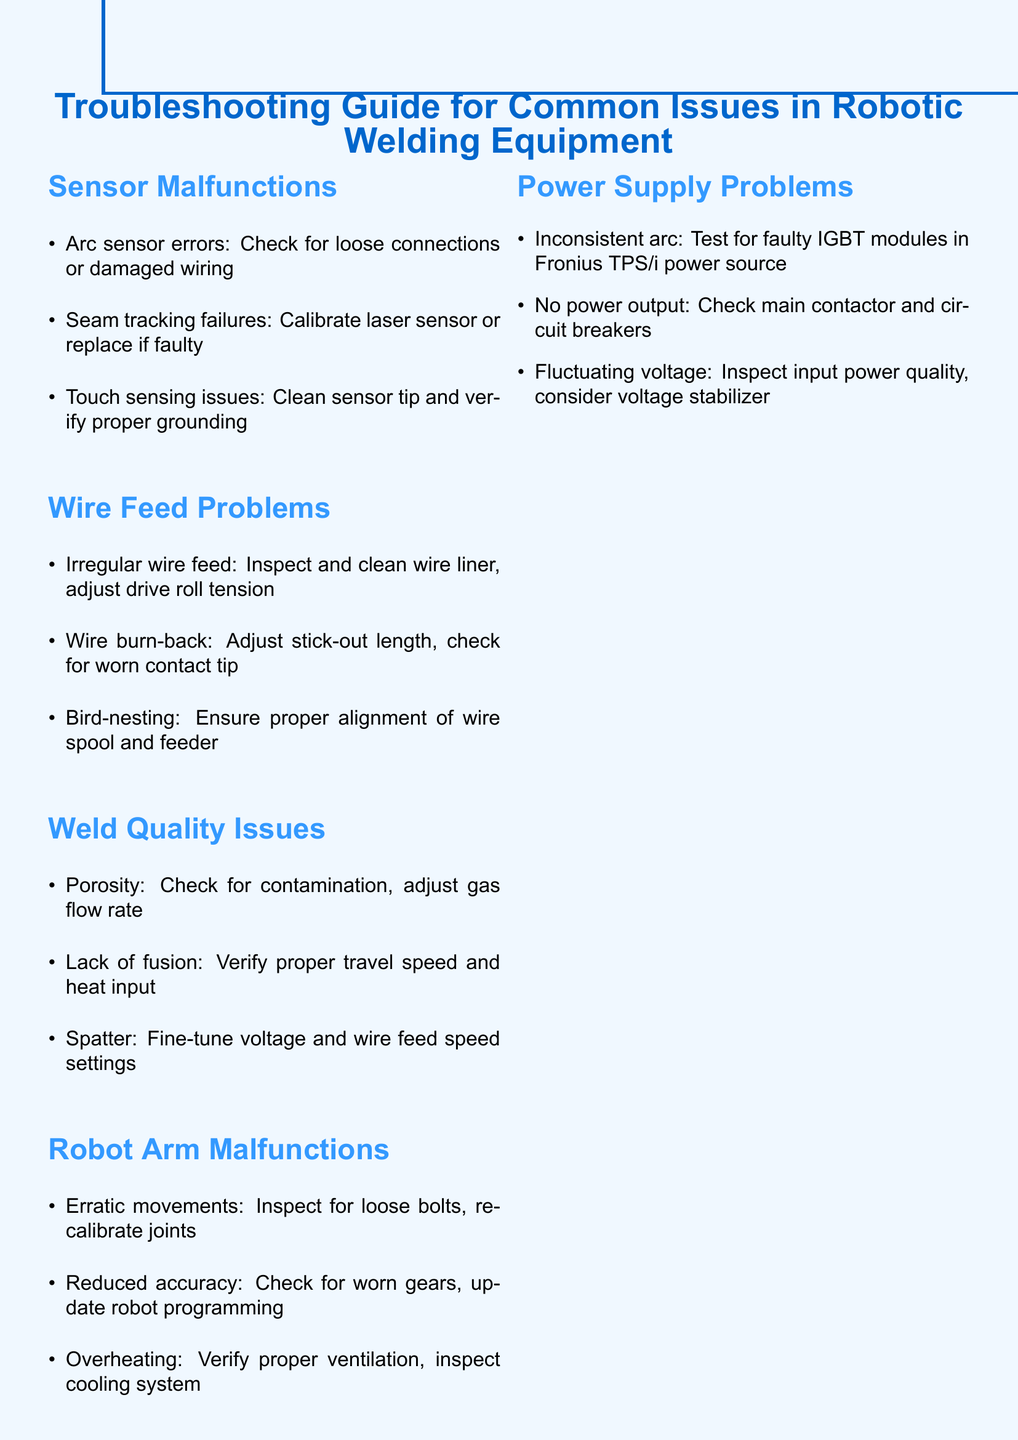What is the first item listed under Sensor Malfunctions? The first item listed is related to arc sensor errors, which states to check for loose connections or damaged wiring.
Answer: Arc sensor errors: Check for loose connections or damaged wiring How many items are listed under Wire Feed Problems? There are a total of three items listed under Wire Feed Problems that describe various issues.
Answer: 3 What should you do if you encounter inconsistent arc? The document suggests testing for faulty IGBT modules in the Fronius TPS/i power source as a troubleshooting step.
Answer: Test for faulty IGBT modules in Fronius TPS/i power source What is a suggested remedy for irregular wire feed? One of the remedies is to inspect and clean the wire liner, as well as adjusting drive roll tension.
Answer: Inspect and clean wire liner, adjust drive roll tension Which section covers issues related to weld quality? The section titled "Weld Quality Issues" specifically addresses problems related to the quality of the weld.
Answer: Weld Quality Issues What is a general note provided at the end of the document? The document includes several general notes, one of which is to always consult the manufacturer's manual for specific troubleshooting steps.
Answer: Always consult the manufacturer's manual for specific troubleshooting steps What issue is addressed if the robot arm experiences erratic movements? The recommended action is to inspect for loose bolts and recalibrate joints, which pertains directly to erratic movements.
Answer: Inspect for loose bolts, recalibrate joints How should one handle power supply problems according to the guide? The guide suggests checking the main contactor and circuit breakers if there is no power output as part of troubleshooting.
Answer: Check main contactor and circuit breakers 